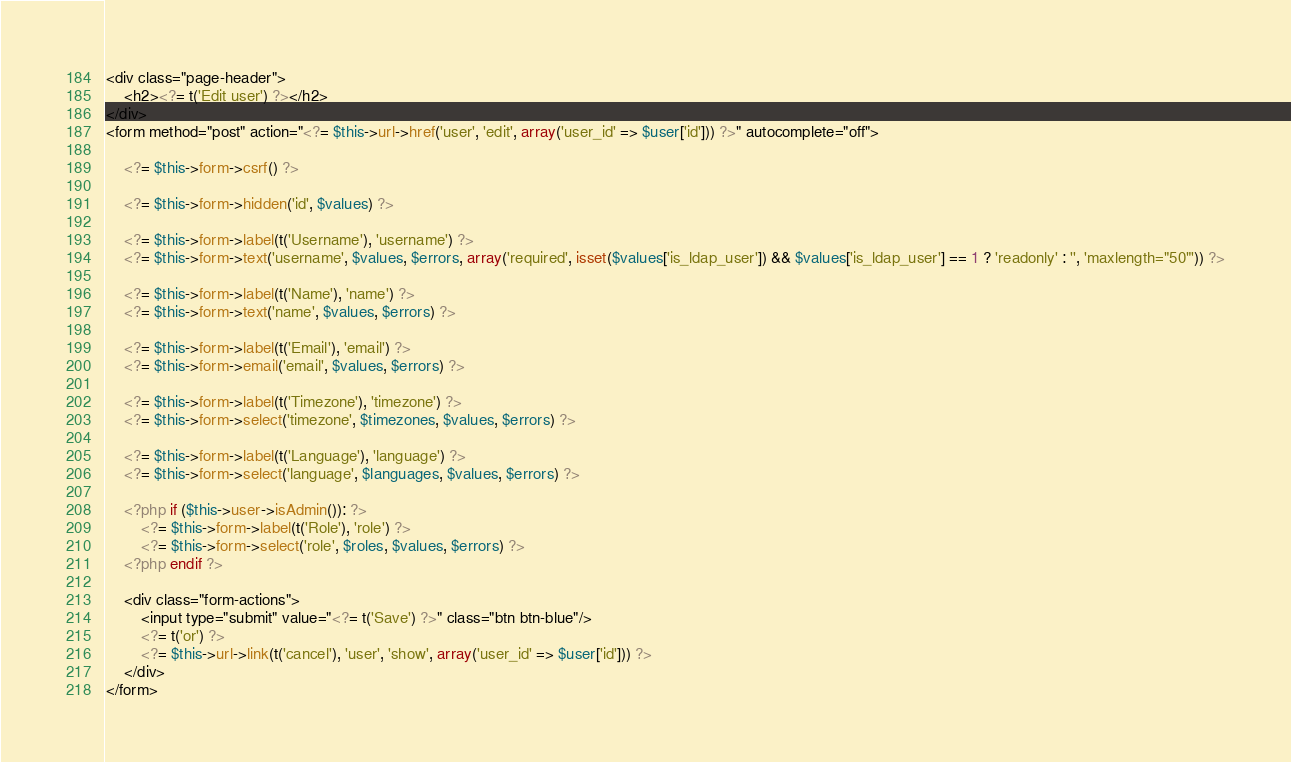<code> <loc_0><loc_0><loc_500><loc_500><_PHP_><div class="page-header">
    <h2><?= t('Edit user') ?></h2>
</div>
<form method="post" action="<?= $this->url->href('user', 'edit', array('user_id' => $user['id'])) ?>" autocomplete="off">

    <?= $this->form->csrf() ?>

    <?= $this->form->hidden('id', $values) ?>

    <?= $this->form->label(t('Username'), 'username') ?>
    <?= $this->form->text('username', $values, $errors, array('required', isset($values['is_ldap_user']) && $values['is_ldap_user'] == 1 ? 'readonly' : '', 'maxlength="50"')) ?>

    <?= $this->form->label(t('Name'), 'name') ?>
    <?= $this->form->text('name', $values, $errors) ?>

    <?= $this->form->label(t('Email'), 'email') ?>
    <?= $this->form->email('email', $values, $errors) ?>

    <?= $this->form->label(t('Timezone'), 'timezone') ?>
    <?= $this->form->select('timezone', $timezones, $values, $errors) ?>

    <?= $this->form->label(t('Language'), 'language') ?>
    <?= $this->form->select('language', $languages, $values, $errors) ?>

    <?php if ($this->user->isAdmin()): ?>
        <?= $this->form->label(t('Role'), 'role') ?>
        <?= $this->form->select('role', $roles, $values, $errors) ?>
    <?php endif ?>

    <div class="form-actions">
        <input type="submit" value="<?= t('Save') ?>" class="btn btn-blue"/>
        <?= t('or') ?>
        <?= $this->url->link(t('cancel'), 'user', 'show', array('user_id' => $user['id'])) ?>
    </div>
</form></code> 